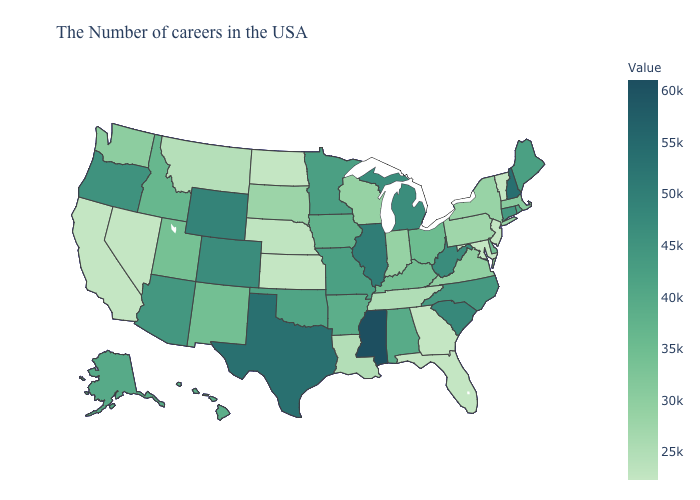Among the states that border Vermont , does New York have the highest value?
Quick response, please. No. Does the map have missing data?
Answer briefly. No. Which states have the lowest value in the USA?
Write a very short answer. Vermont, New Jersey, Maryland, Georgia, Kansas, North Dakota, Nevada, California. Which states have the lowest value in the MidWest?
Write a very short answer. Kansas, North Dakota. Among the states that border Missouri , which have the highest value?
Short answer required. Illinois. 